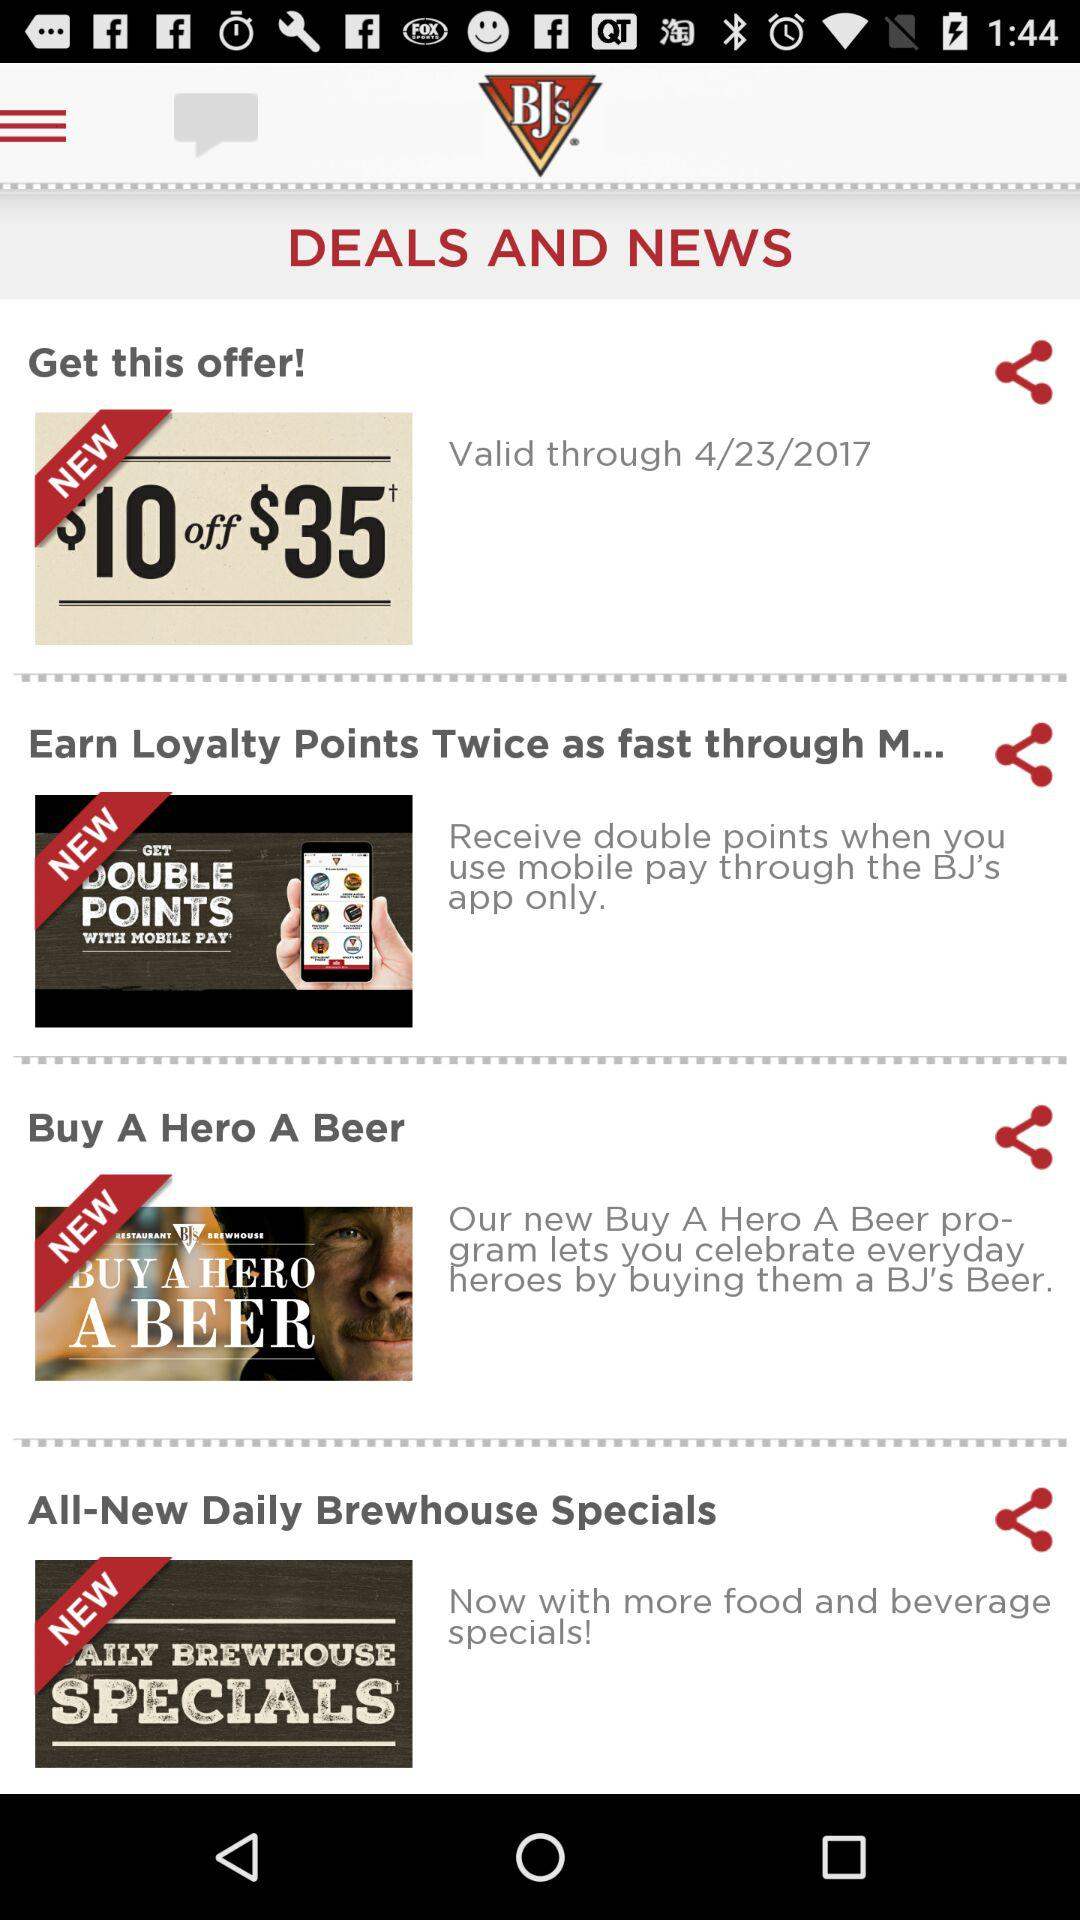What is the validity date? The validity date is April 23, 2017. 